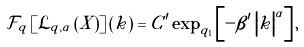<formula> <loc_0><loc_0><loc_500><loc_500>\mathcal { F } _ { q } \left [ \mathcal { L } _ { q , \alpha } \left ( X \right ) \right ] \left ( k \right ) = C ^ { \prime } \exp _ { q _ { 1 } } \left [ - \beta ^ { \prime } \left | k \right | ^ { \alpha } \right ] ,</formula> 